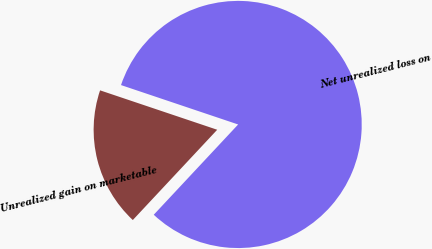<chart> <loc_0><loc_0><loc_500><loc_500><pie_chart><fcel>Net unrealized loss on<fcel>Unrealized gain on marketable<nl><fcel>81.8%<fcel>18.2%<nl></chart> 